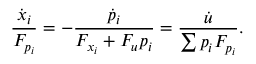<formula> <loc_0><loc_0><loc_500><loc_500>{ \frac { { \dot { x } } _ { i } } { F _ { p _ { i } } } } = - { \frac { { \dot { p } } _ { i } } { F _ { x _ { i } } + F _ { u } p _ { i } } } = { \frac { \dot { u } } { \sum p _ { i } F _ { p _ { i } } } } .</formula> 